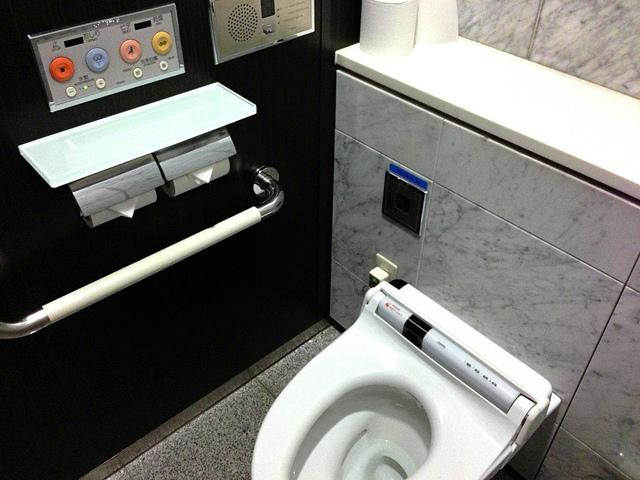Where is the tissue?
Answer briefly. On wall. Why are the buttons on the wall different colors?
Give a very brief answer. Different kinds of soap. Is this restroom in a public place or a private residence?
Give a very brief answer. Public. 